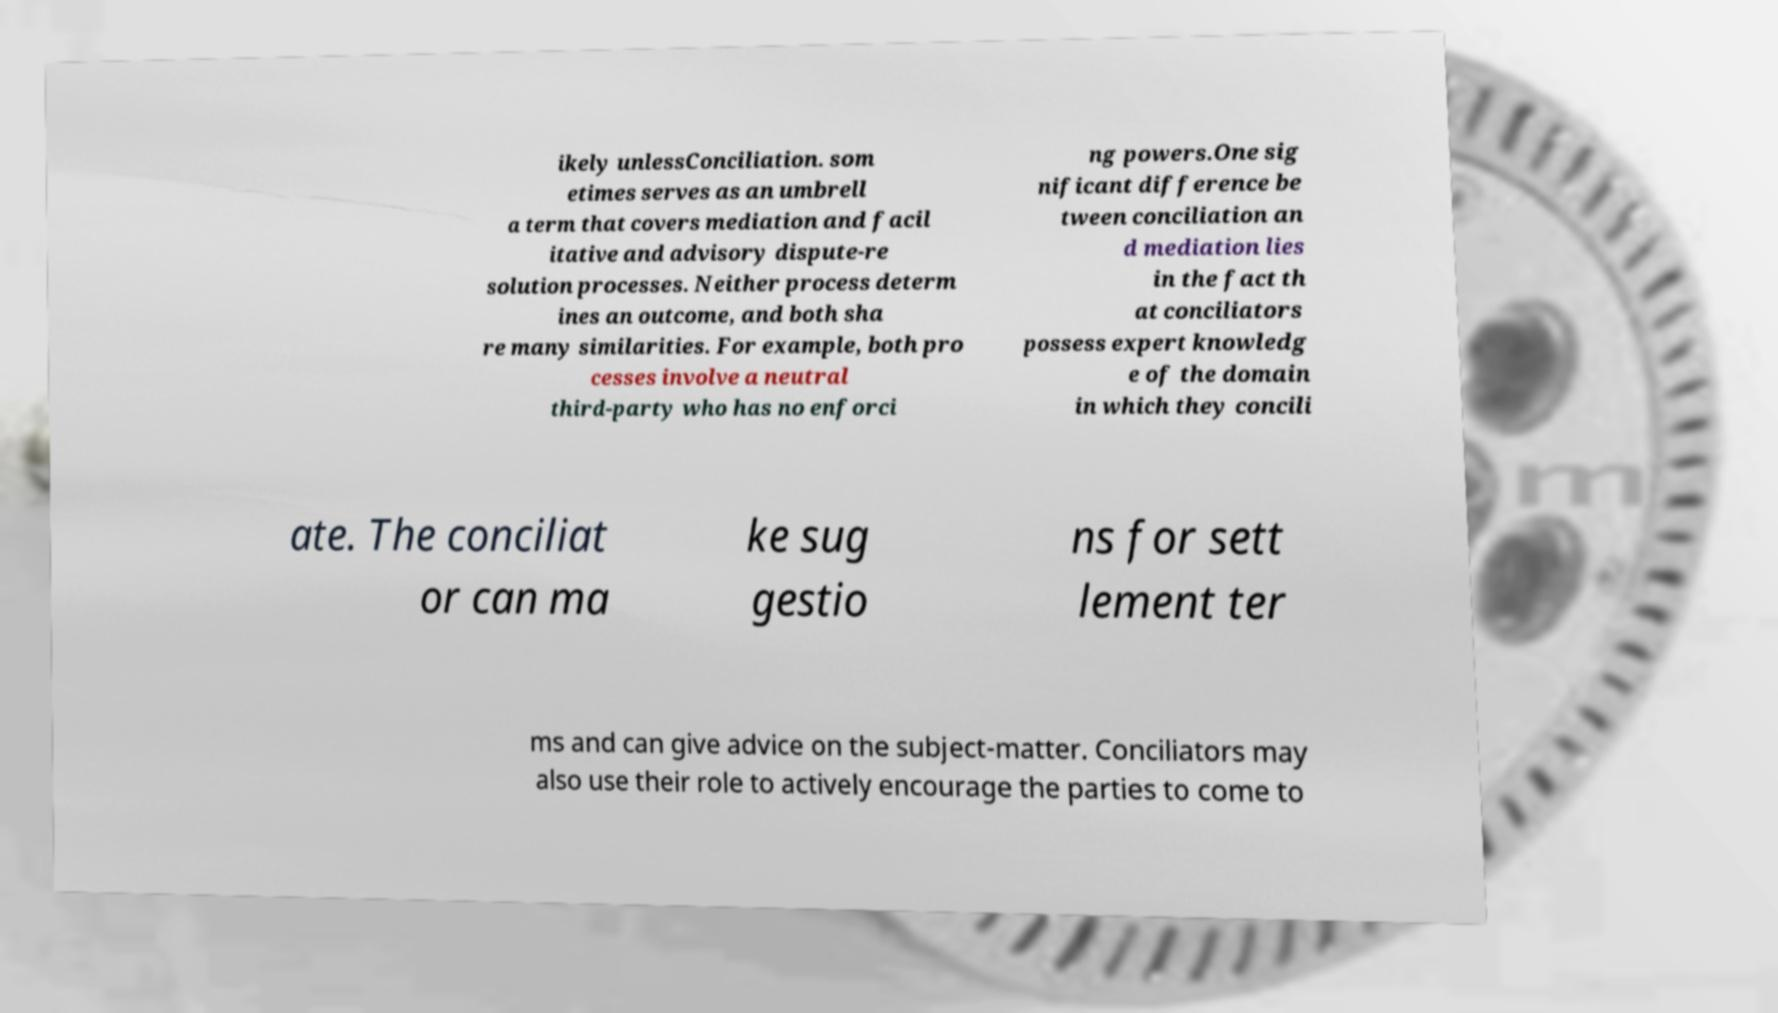Could you assist in decoding the text presented in this image and type it out clearly? ikely unlessConciliation. som etimes serves as an umbrell a term that covers mediation and facil itative and advisory dispute-re solution processes. Neither process determ ines an outcome, and both sha re many similarities. For example, both pro cesses involve a neutral third-party who has no enforci ng powers.One sig nificant difference be tween conciliation an d mediation lies in the fact th at conciliators possess expert knowledg e of the domain in which they concili ate. The conciliat or can ma ke sug gestio ns for sett lement ter ms and can give advice on the subject-matter. Conciliators may also use their role to actively encourage the parties to come to 